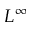Convert formula to latex. <formula><loc_0><loc_0><loc_500><loc_500>L ^ { \infty }</formula> 